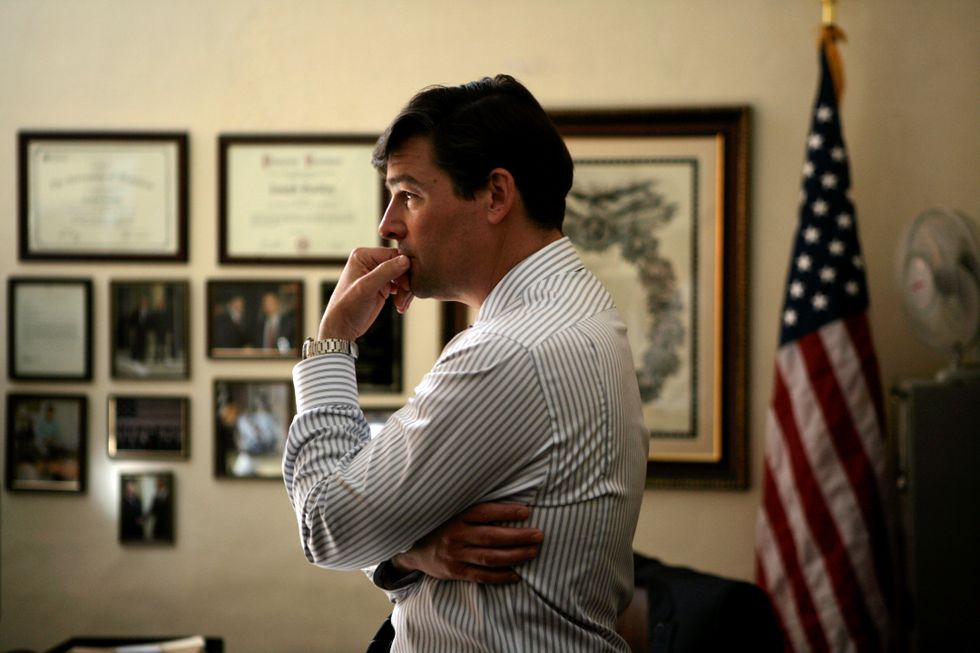Imagine if this scene was part of a suspenseful movie. What could be the story leading up to this moment? In a suspenseful movie, this scene could depict a crucial moment where the protagonist, a government official or a daring investigator, is contemplating a challenging decision. Leading up to this moment, he might have uncovered a conspiracy that threatens national security. The certificates behind him reflect his credentials and the trust placed in him by his superiors. With the American flag symbolizing his dedication to the country, he's now weighing the considerable risks and impacts of exposing or confronting the threat, knowing it could endanger his career, his reputation, and perhaps even his life. What could be the next scene in this suspenseful movie? The next scene could see the protagonist making a bold decision. He picks up the phone, hesitates for a moment, and then calls his most trusted ally. The conversation is intense and filled with tension as they discuss their next moves. The camera then shifts to a darker room where shadowy figures are plotting against him, unaware that he's already one step ahead. This sets the stage for an intense cat-and-mouse game between the protagonist and the antagonists, filled with twists and turns that keep the audience on the edge of their seats. What if this scene was part of a science fiction story set in the future? If set in a science fiction future, the room could belong to a high-ranking officer of a space fleet, perhaps stationed on a starship. The certificates could represent commendations from intergalactic missions, and the photos could depict various alien worlds and spacecraft. The American flag might be replaced by a flag of an interstellar federation. In this context, the officer is troubled by a mysterious signal from the far reaches of space, suggesting the presence of an unknown and possibly hostile alien civilization. The officer's body language reflects the heavy burden of responsibility as he prepares to make a decision that could alter the fate of multiple planets. 